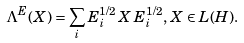<formula> <loc_0><loc_0><loc_500><loc_500>\Lambda ^ { E } ( X ) = \sum _ { i } E _ { i } ^ { 1 / 2 } \, X \, E _ { i } ^ { 1 / 2 } , \, X \in L ( H ) .</formula> 